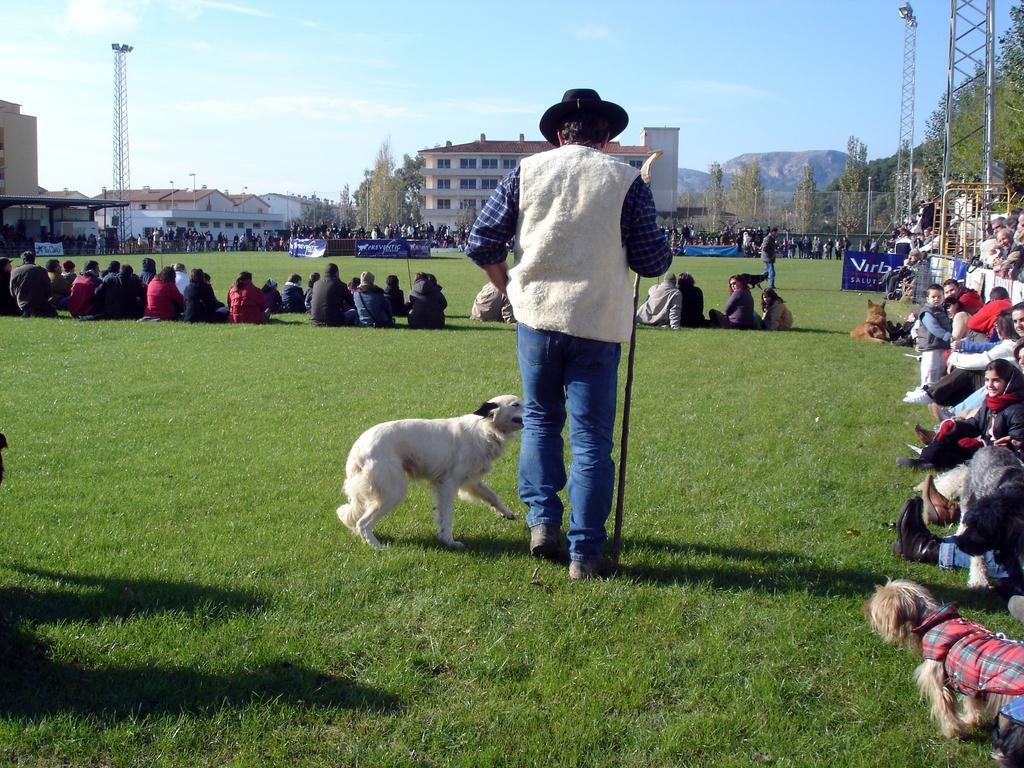How would you summarize this image in a sentence or two? In this image there are people, dog in the foreground. There is a green grass at the bottom. There are people, poles and trees in the right corner. There are buildings, trees,mountains, people in the right corner. And There is a sky at the top. 